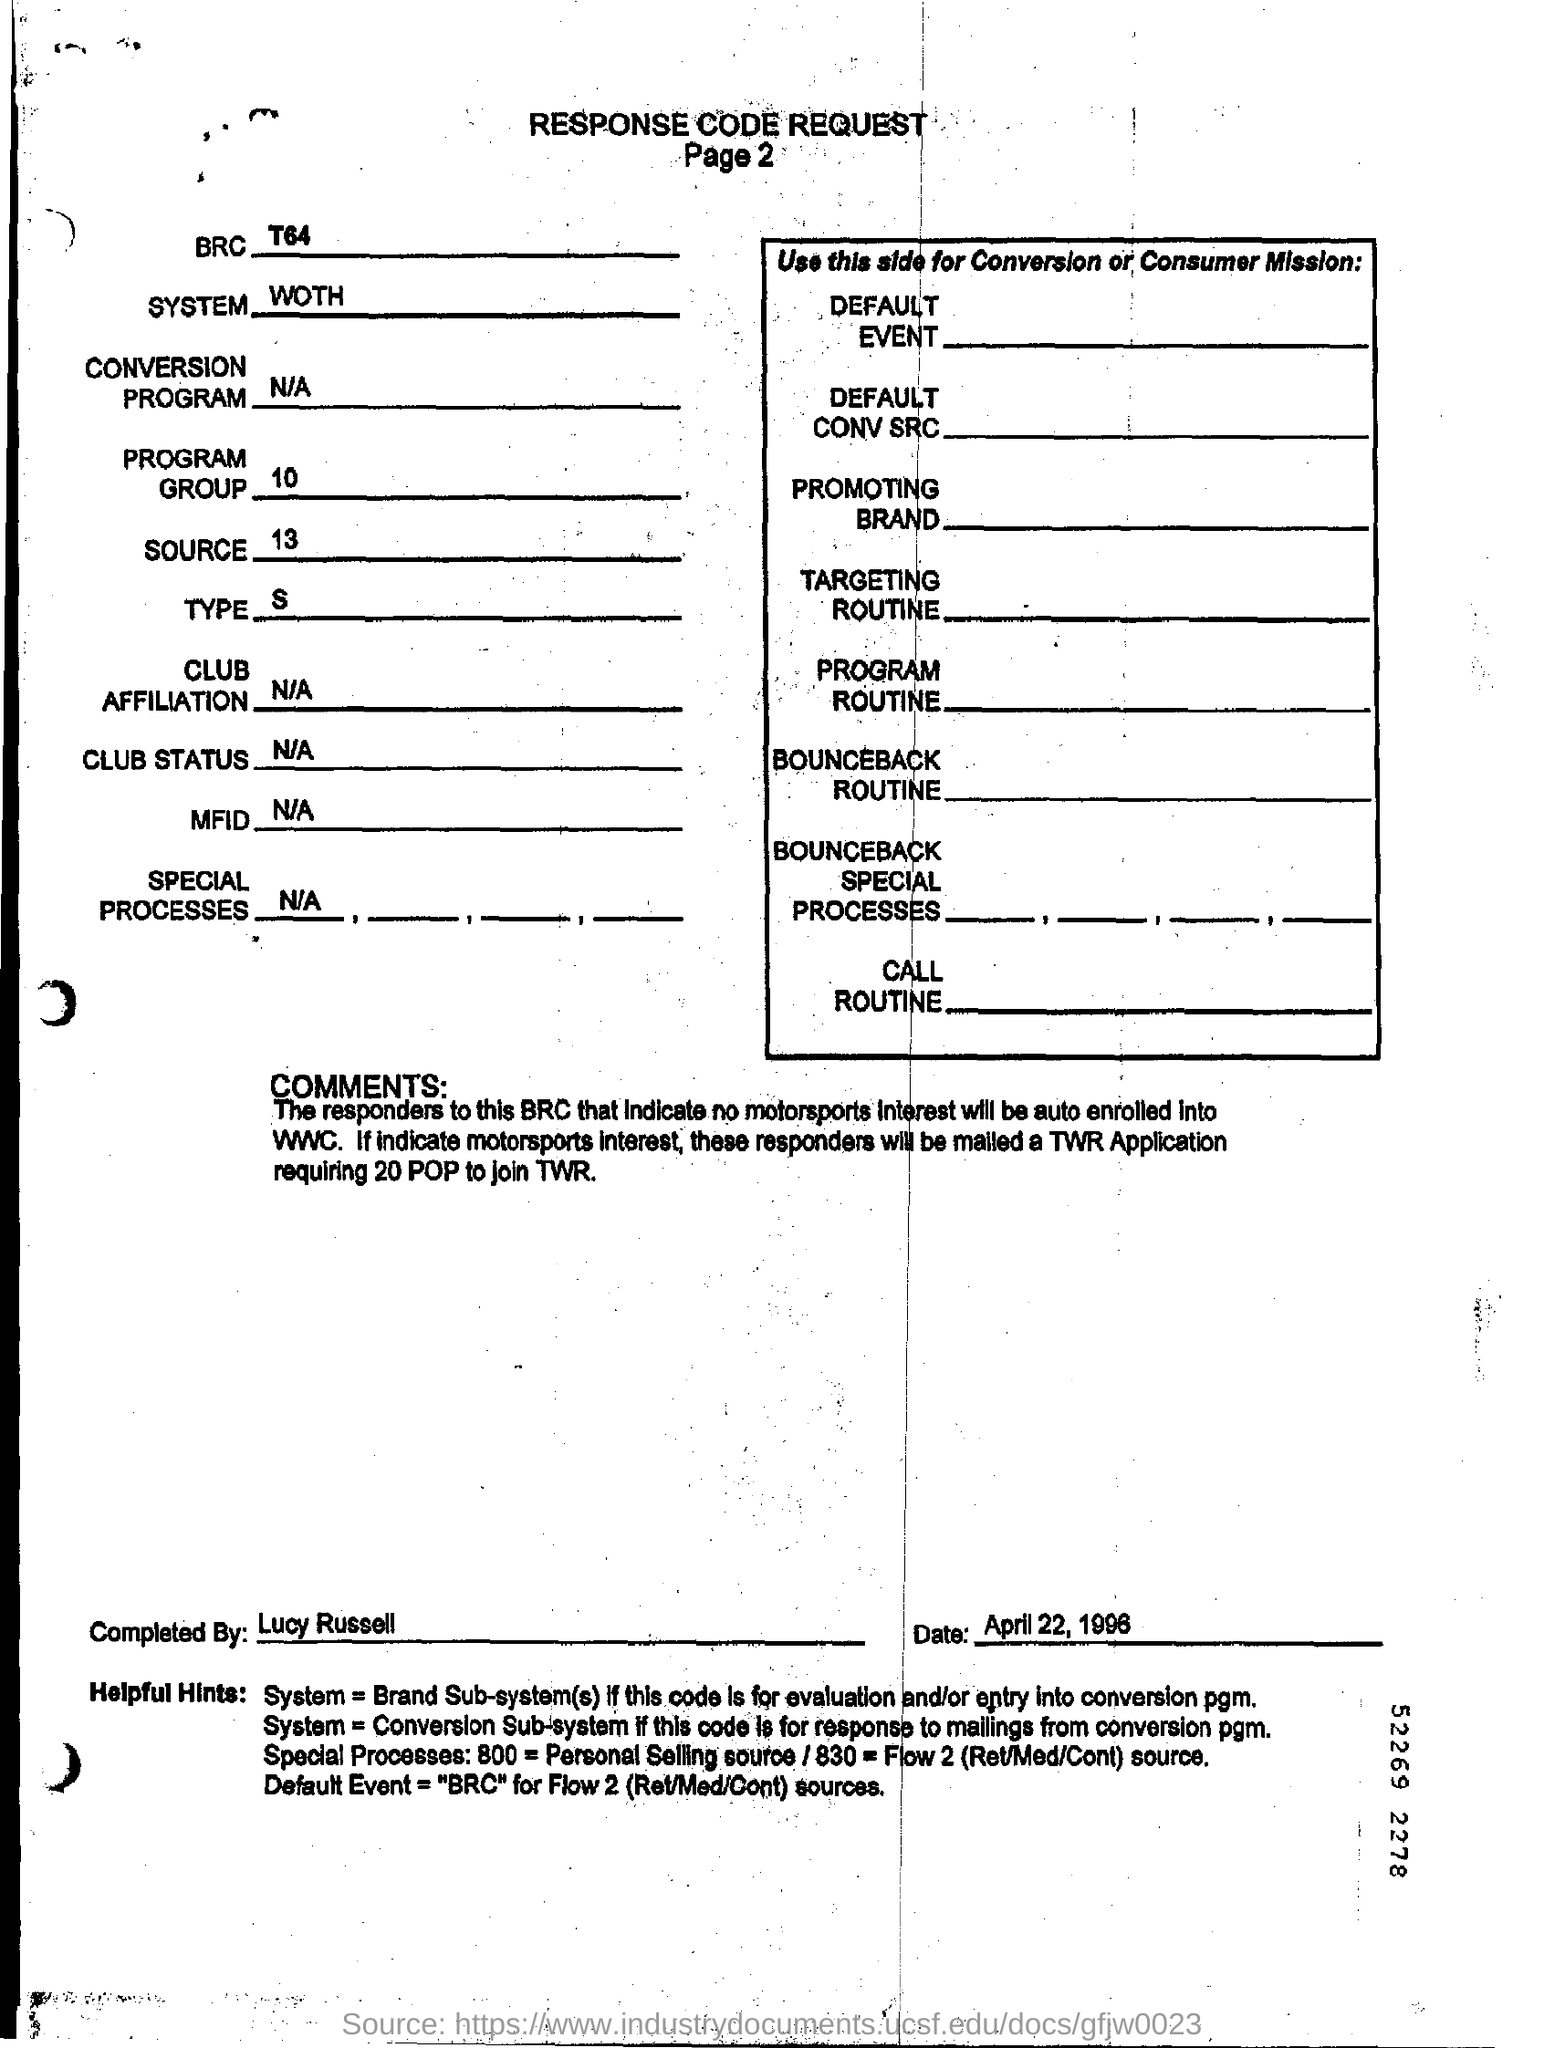What is the number of page of this document?
Provide a succinct answer. 2. What is the number of Program Group?
Your answer should be very brief. 10. What is "type" mentioned in the document?
Offer a very short reply. S. Who completed this document?
Your answer should be compact. Lucy Russell. What is the date of the document?
Your answer should be very brief. April 22, 1996. 